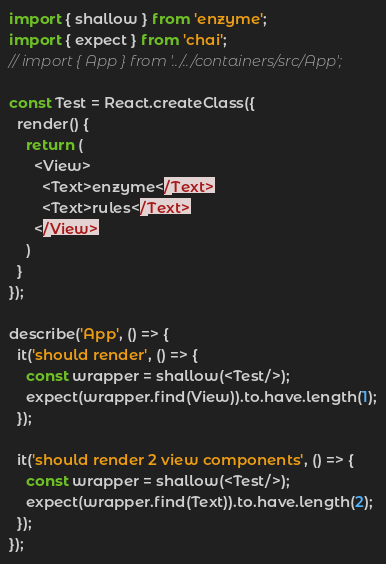<code> <loc_0><loc_0><loc_500><loc_500><_JavaScript_>import { shallow } from 'enzyme';
import { expect } from 'chai';
// import { App } from '../../containers/src/App';

const Test = React.createClass({
  render() {
    return (
      <View>
        <Text>enzyme</Text>
        <Text>rules</Text>
      </View>
    )
  }
});

describe('App', () => {
  it('should render', () => {
    const wrapper = shallow(<Test/>);
    expect(wrapper.find(View)).to.have.length(1);
  });

  it('should render 2 view components', () => {
    const wrapper = shallow(<Test/>);
    expect(wrapper.find(Text)).to.have.length(2);
  });
});
</code> 